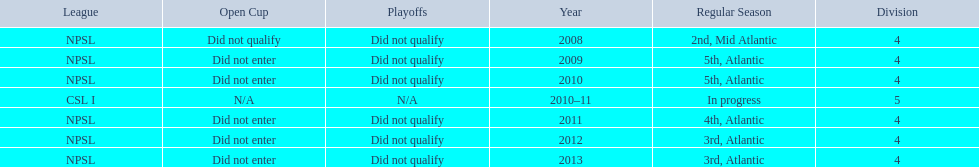Give me the full table as a dictionary. {'header': ['League', 'Open Cup', 'Playoffs', 'Year', 'Regular Season', 'Division'], 'rows': [['NPSL', 'Did not qualify', 'Did not qualify', '2008', '2nd, Mid Atlantic', '4'], ['NPSL', 'Did not enter', 'Did not qualify', '2009', '5th, Atlantic', '4'], ['NPSL', 'Did not enter', 'Did not qualify', '2010', '5th, Atlantic', '4'], ['CSL I', 'N/A', 'N/A', '2010–11', 'In progress', '5'], ['NPSL', 'Did not enter', 'Did not qualify', '2011', '4th, Atlantic', '4'], ['NPSL', 'Did not enter', 'Did not qualify', '2012', '3rd, Atlantic', '4'], ['NPSL', 'Did not enter', 'Did not qualify', '2013', '3rd, Atlantic', '4']]} What are the names of the leagues? NPSL, CSL I. Which league other than npsl did ny soccer team play under? CSL I. 